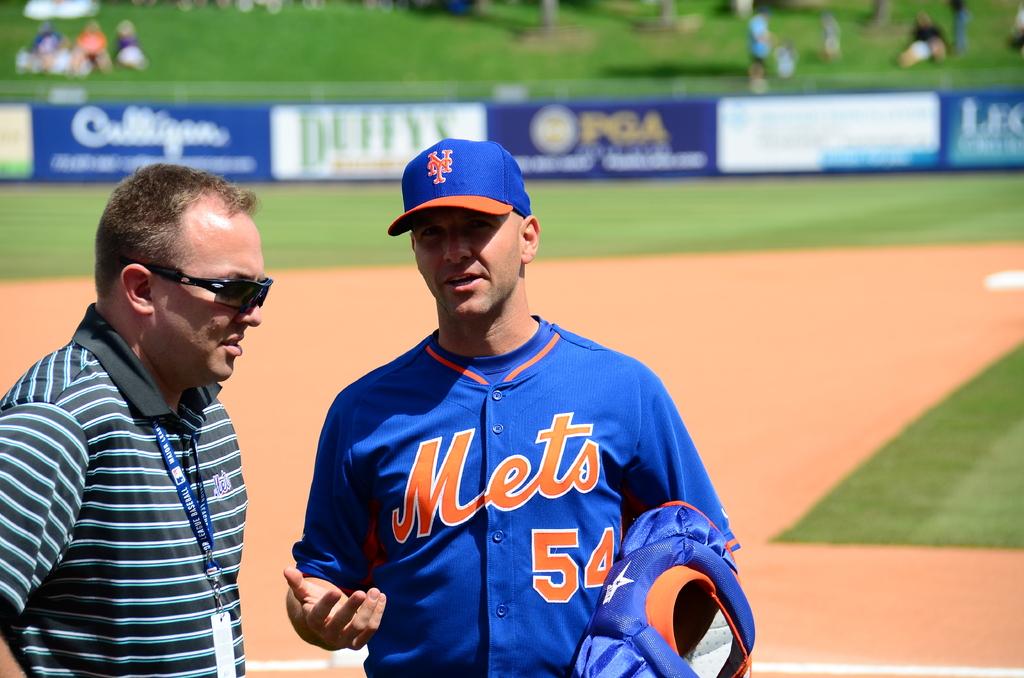What is his jersey number?
Your answer should be very brief. 54. 